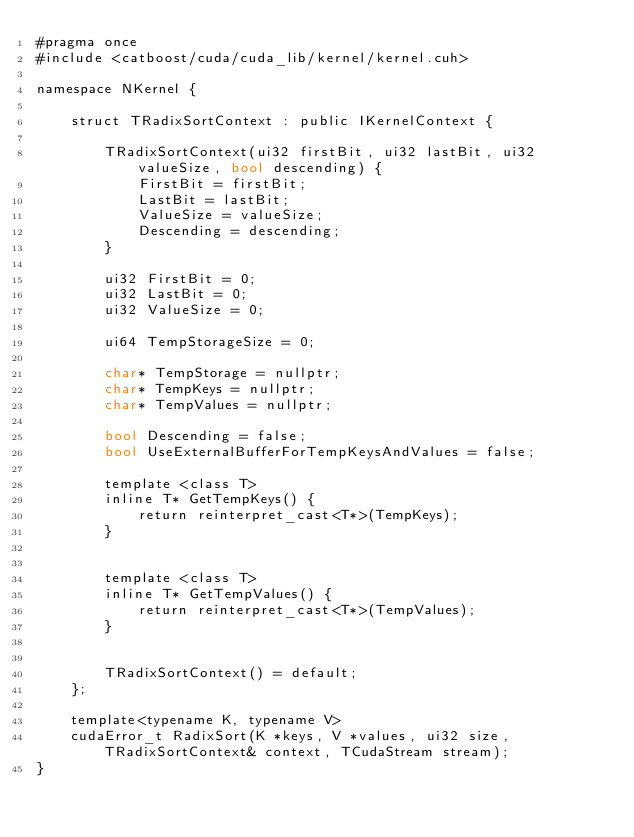<code> <loc_0><loc_0><loc_500><loc_500><_Cuda_>#pragma once
#include <catboost/cuda/cuda_lib/kernel/kernel.cuh>

namespace NKernel {

    struct TRadixSortContext : public IKernelContext {

        TRadixSortContext(ui32 firstBit, ui32 lastBit, ui32 valueSize, bool descending) {
            FirstBit = firstBit;
            LastBit = lastBit;
            ValueSize = valueSize;
            Descending = descending;
        }

        ui32 FirstBit = 0;
        ui32 LastBit = 0;
        ui32 ValueSize = 0;

        ui64 TempStorageSize = 0;

        char* TempStorage = nullptr;
        char* TempKeys = nullptr;
        char* TempValues = nullptr;

        bool Descending = false;
        bool UseExternalBufferForTempKeysAndValues = false;

        template <class T>
        inline T* GetTempKeys() {
            return reinterpret_cast<T*>(TempKeys);
        }


        template <class T>
        inline T* GetTempValues() {
            return reinterpret_cast<T*>(TempValues);
        }


        TRadixSortContext() = default;
    };

    template<typename K, typename V>
    cudaError_t RadixSort(K *keys, V *values, ui32 size, TRadixSortContext& context, TCudaStream stream);
}
</code> 